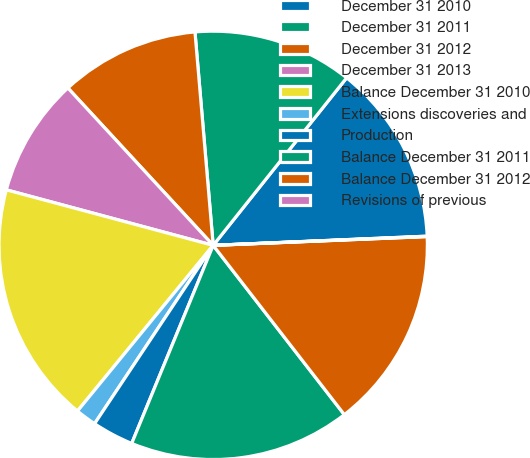<chart> <loc_0><loc_0><loc_500><loc_500><pie_chart><fcel>December 31 2010<fcel>December 31 2011<fcel>December 31 2012<fcel>December 31 2013<fcel>Balance December 31 2010<fcel>Extensions discoveries and<fcel>Production<fcel>Balance December 31 2011<fcel>Balance December 31 2012<fcel>Revisions of previous<nl><fcel>13.61%<fcel>12.06%<fcel>10.51%<fcel>8.96%<fcel>18.25%<fcel>1.58%<fcel>3.13%<fcel>16.7%<fcel>15.16%<fcel>0.03%<nl></chart> 